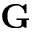Convert formula to latex. <formula><loc_0><loc_0><loc_500><loc_500>G</formula> 